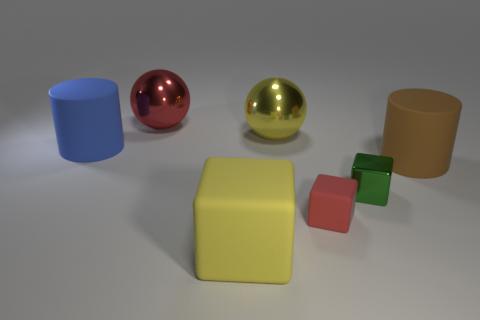How big is the metallic object that is in front of the big yellow object that is behind the big matte block that is right of the big blue matte cylinder?
Offer a terse response. Small. The rubber object behind the large rubber cylinder to the right of the blue rubber object is what color?
Your answer should be compact. Blue. There is another thing that is the same shape as the large brown rubber thing; what material is it?
Make the answer very short. Rubber. Is there anything else that has the same material as the green thing?
Your answer should be very brief. Yes. There is a tiny green metal block; are there any blocks right of it?
Your answer should be very brief. No. What number of big objects are there?
Make the answer very short. 5. How many large rubber cylinders are left of the cylinder that is right of the blue cylinder?
Your answer should be compact. 1. There is a big cube; is it the same color as the matte cylinder left of the small green block?
Provide a short and direct response. No. What number of yellow matte objects have the same shape as the tiny red rubber thing?
Offer a very short reply. 1. What material is the large cylinder that is on the right side of the red metal sphere?
Provide a succinct answer. Rubber. 